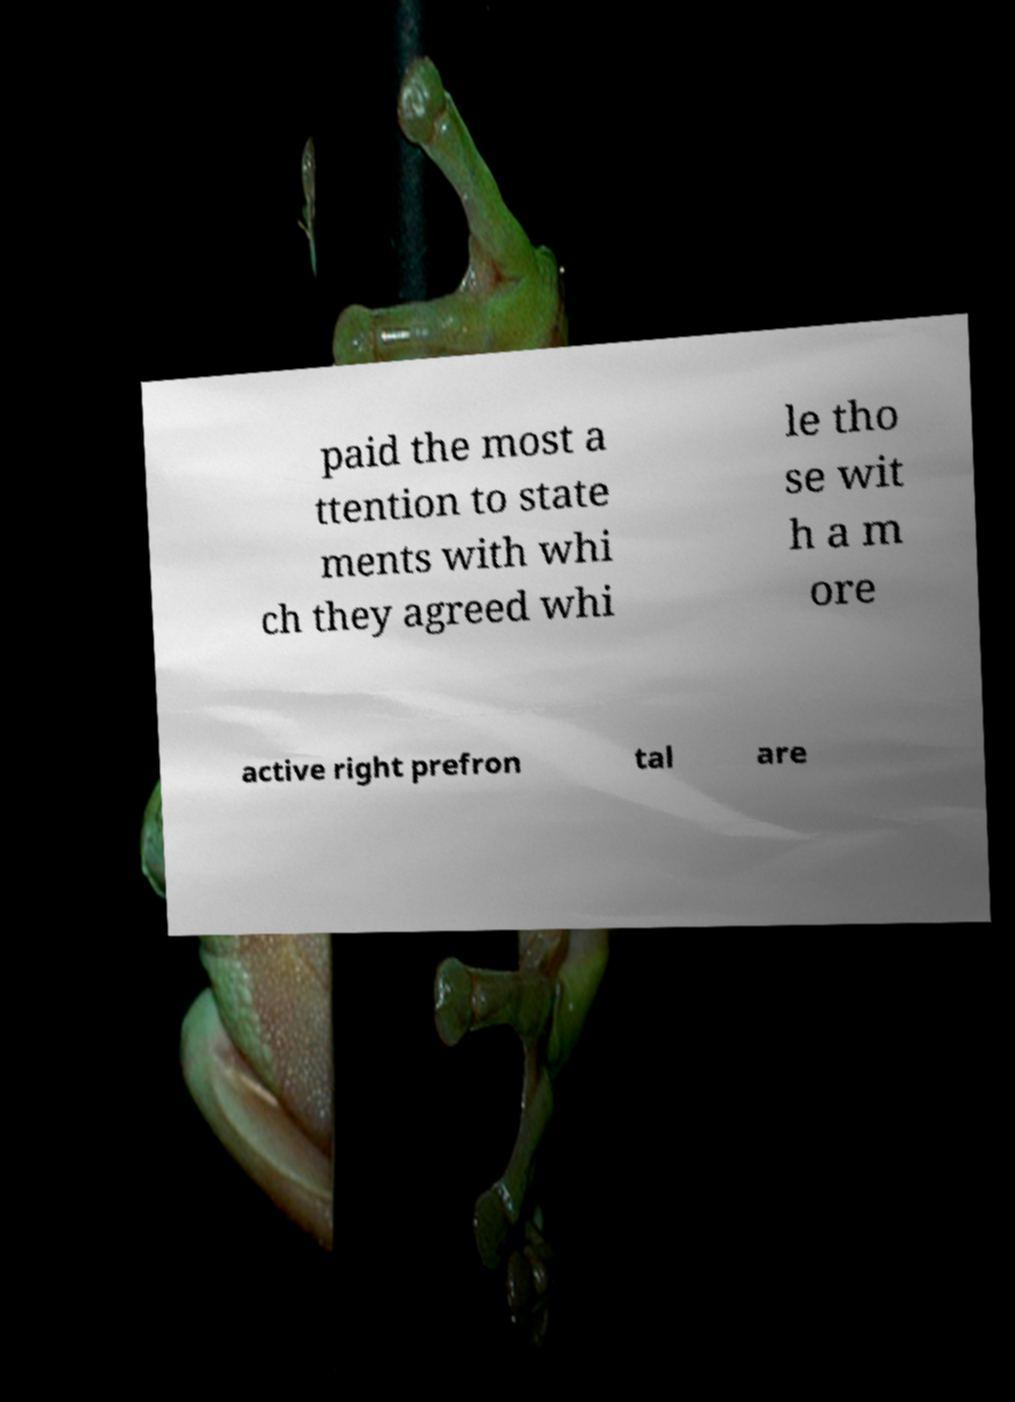Can you read and provide the text displayed in the image?This photo seems to have some interesting text. Can you extract and type it out for me? paid the most a ttention to state ments with whi ch they agreed whi le tho se wit h a m ore active right prefron tal are 